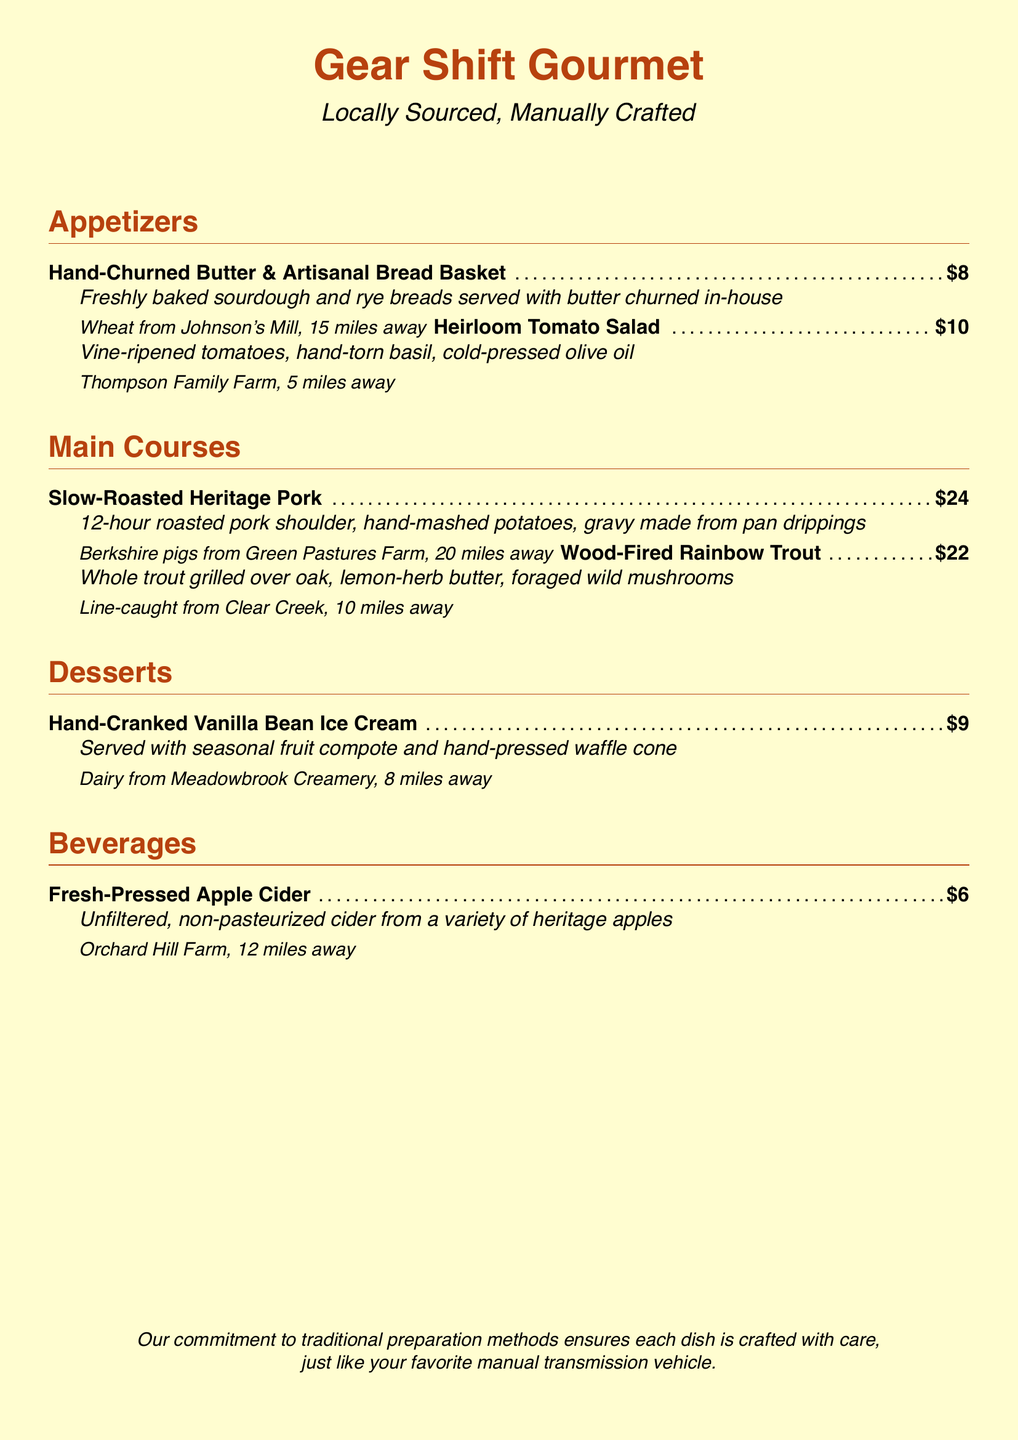What is the name of the restaurant? The name of the restaurant is highlighted prominently at the top of the menu.
Answer: Gear Shift Gourmet How much is the Heirloom Tomato Salad? The price of the Heirloom Tomato Salad is listed next to the dish name.
Answer: $10 What farm supplies the wheat for the bread? The source of the wheat is mentioned alongside the Hand-Churned Butter & Artisanal Bread Basket.
Answer: Johnson's Mill How far away is the Meadowbrook Creamery? The distance is provided for each ingredient source in the document.
Answer: 8 miles Which dish features foraged wild mushrooms? The dishes typically include details about their unique ingredients.
Answer: Wood-Fired Rainbow Trout What preparation method is used for the Heritage Pork? The preparation method is described in detail in the dish description area.
Answer: Slow-Roasted What type of dessert is served with a hand-pressed waffle cone? The dessert type includes specifics in its description to highlight techniques.
Answer: Hand-Cranked Vanilla Bean Ice Cream What does the restaurant promote in terms of preparation methods? The commitment to preparation methods is summarized at the bottom of the menu.
Answer: Traditional preparation methods How much does the Fresh-Pressed Apple Cider cost? The cost of beverages is displayed next to their names.
Answer: $6 